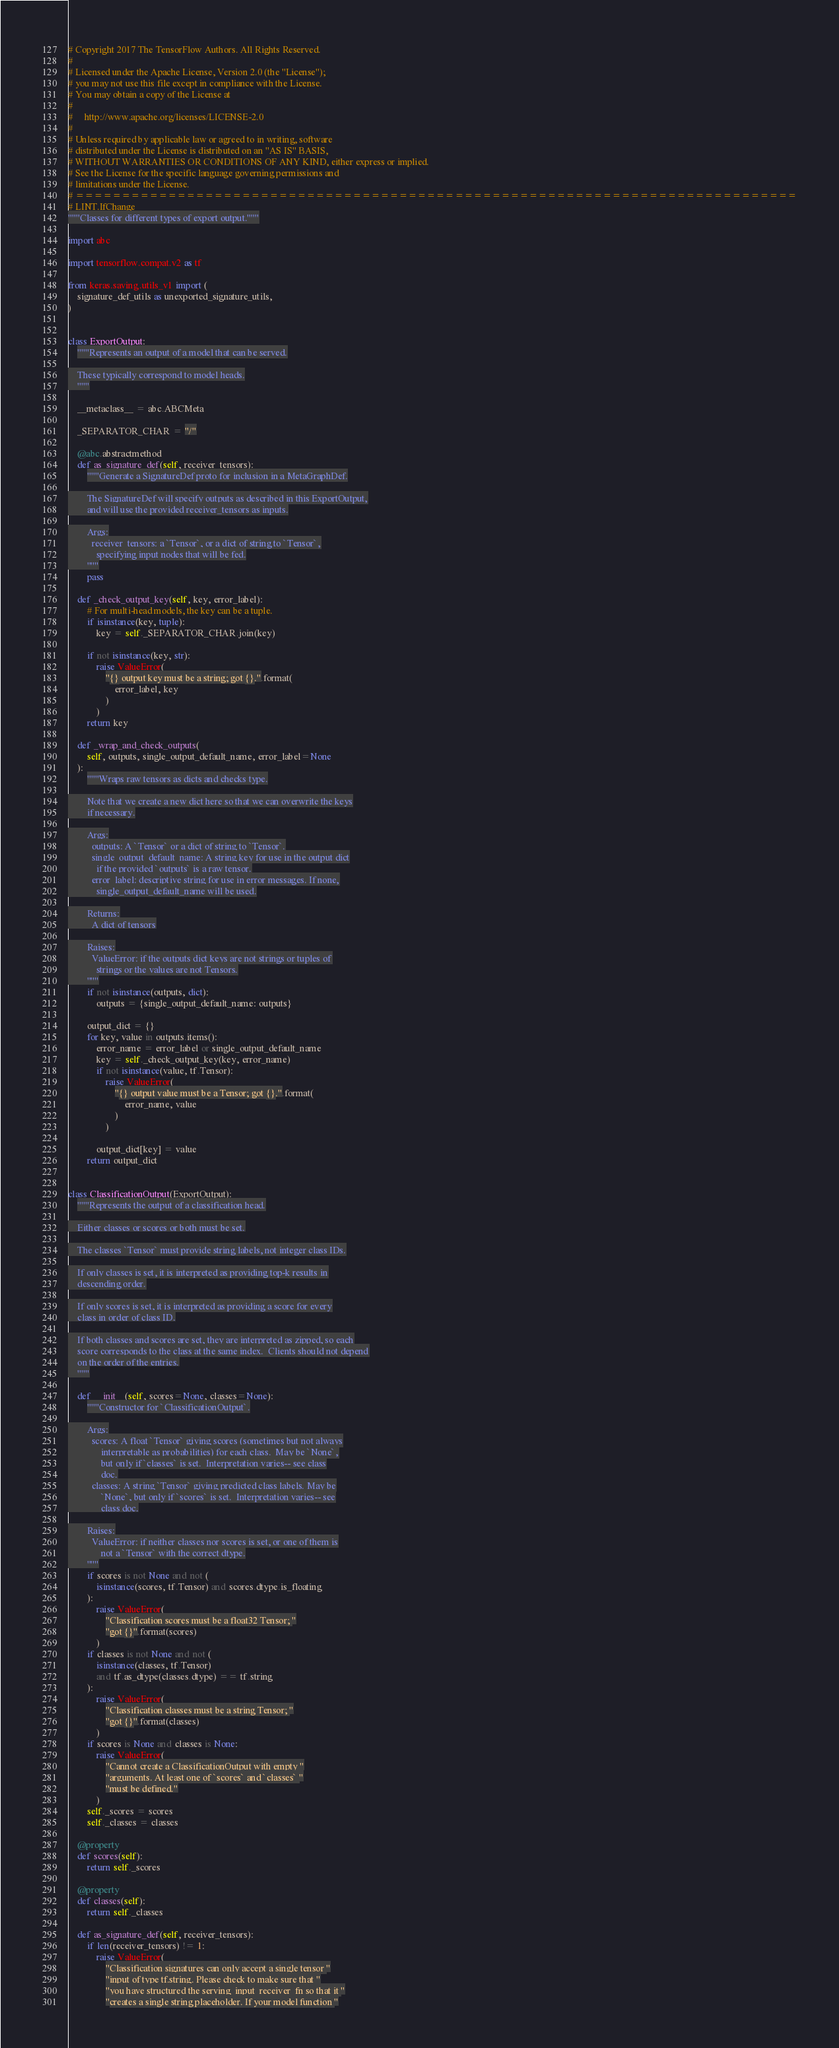Convert code to text. <code><loc_0><loc_0><loc_500><loc_500><_Python_># Copyright 2017 The TensorFlow Authors. All Rights Reserved.
#
# Licensed under the Apache License, Version 2.0 (the "License");
# you may not use this file except in compliance with the License.
# You may obtain a copy of the License at
#
#     http://www.apache.org/licenses/LICENSE-2.0
#
# Unless required by applicable law or agreed to in writing, software
# distributed under the License is distributed on an "AS IS" BASIS,
# WITHOUT WARRANTIES OR CONDITIONS OF ANY KIND, either express or implied.
# See the License for the specific language governing permissions and
# limitations under the License.
# ==============================================================================
# LINT.IfChange
"""Classes for different types of export output."""

import abc

import tensorflow.compat.v2 as tf

from keras.saving.utils_v1 import (
    signature_def_utils as unexported_signature_utils,
)


class ExportOutput:
    """Represents an output of a model that can be served.

    These typically correspond to model heads.
    """

    __metaclass__ = abc.ABCMeta

    _SEPARATOR_CHAR = "/"

    @abc.abstractmethod
    def as_signature_def(self, receiver_tensors):
        """Generate a SignatureDef proto for inclusion in a MetaGraphDef.

        The SignatureDef will specify outputs as described in this ExportOutput,
        and will use the provided receiver_tensors as inputs.

        Args:
          receiver_tensors: a `Tensor`, or a dict of string to `Tensor`,
            specifying input nodes that will be fed.
        """
        pass

    def _check_output_key(self, key, error_label):
        # For multi-head models, the key can be a tuple.
        if isinstance(key, tuple):
            key = self._SEPARATOR_CHAR.join(key)

        if not isinstance(key, str):
            raise ValueError(
                "{} output key must be a string; got {}.".format(
                    error_label, key
                )
            )
        return key

    def _wrap_and_check_outputs(
        self, outputs, single_output_default_name, error_label=None
    ):
        """Wraps raw tensors as dicts and checks type.

        Note that we create a new dict here so that we can overwrite the keys
        if necessary.

        Args:
          outputs: A `Tensor` or a dict of string to `Tensor`.
          single_output_default_name: A string key for use in the output dict
            if the provided `outputs` is a raw tensor.
          error_label: descriptive string for use in error messages. If none,
            single_output_default_name will be used.

        Returns:
          A dict of tensors

        Raises:
          ValueError: if the outputs dict keys are not strings or tuples of
            strings or the values are not Tensors.
        """
        if not isinstance(outputs, dict):
            outputs = {single_output_default_name: outputs}

        output_dict = {}
        for key, value in outputs.items():
            error_name = error_label or single_output_default_name
            key = self._check_output_key(key, error_name)
            if not isinstance(value, tf.Tensor):
                raise ValueError(
                    "{} output value must be a Tensor; got {}.".format(
                        error_name, value
                    )
                )

            output_dict[key] = value
        return output_dict


class ClassificationOutput(ExportOutput):
    """Represents the output of a classification head.

    Either classes or scores or both must be set.

    The classes `Tensor` must provide string labels, not integer class IDs.

    If only classes is set, it is interpreted as providing top-k results in
    descending order.

    If only scores is set, it is interpreted as providing a score for every
    class in order of class ID.

    If both classes and scores are set, they are interpreted as zipped, so each
    score corresponds to the class at the same index.  Clients should not depend
    on the order of the entries.
    """

    def __init__(self, scores=None, classes=None):
        """Constructor for `ClassificationOutput`.

        Args:
          scores: A float `Tensor` giving scores (sometimes but not always
              interpretable as probabilities) for each class.  May be `None`,
              but only if `classes` is set.  Interpretation varies-- see class
              doc.
          classes: A string `Tensor` giving predicted class labels. May be
              `None`, but only if `scores` is set.  Interpretation varies-- see
              class doc.

        Raises:
          ValueError: if neither classes nor scores is set, or one of them is
              not a `Tensor` with the correct dtype.
        """
        if scores is not None and not (
            isinstance(scores, tf.Tensor) and scores.dtype.is_floating
        ):
            raise ValueError(
                "Classification scores must be a float32 Tensor; "
                "got {}".format(scores)
            )
        if classes is not None and not (
            isinstance(classes, tf.Tensor)
            and tf.as_dtype(classes.dtype) == tf.string
        ):
            raise ValueError(
                "Classification classes must be a string Tensor; "
                "got {}".format(classes)
            )
        if scores is None and classes is None:
            raise ValueError(
                "Cannot create a ClassificationOutput with empty "
                "arguments. At least one of `scores` and `classes` "
                "must be defined."
            )
        self._scores = scores
        self._classes = classes

    @property
    def scores(self):
        return self._scores

    @property
    def classes(self):
        return self._classes

    def as_signature_def(self, receiver_tensors):
        if len(receiver_tensors) != 1:
            raise ValueError(
                "Classification signatures can only accept a single tensor "
                "input of type tf.string. Please check to make sure that "
                "you have structured the serving_input_receiver_fn so that it "
                "creates a single string placeholder. If your model function "</code> 